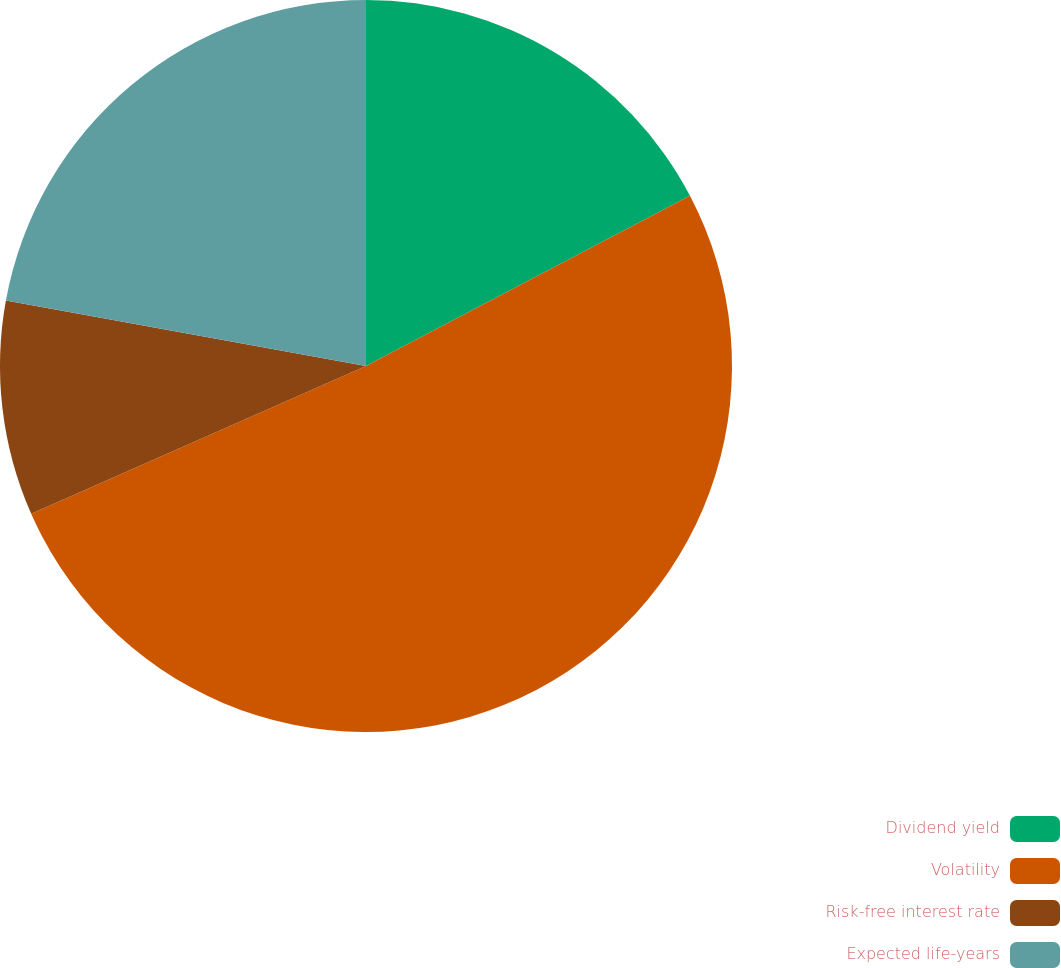<chart> <loc_0><loc_0><loc_500><loc_500><pie_chart><fcel>Dividend yield<fcel>Volatility<fcel>Risk-free interest rate<fcel>Expected life-years<nl><fcel>17.3%<fcel>51.09%<fcel>9.48%<fcel>22.14%<nl></chart> 